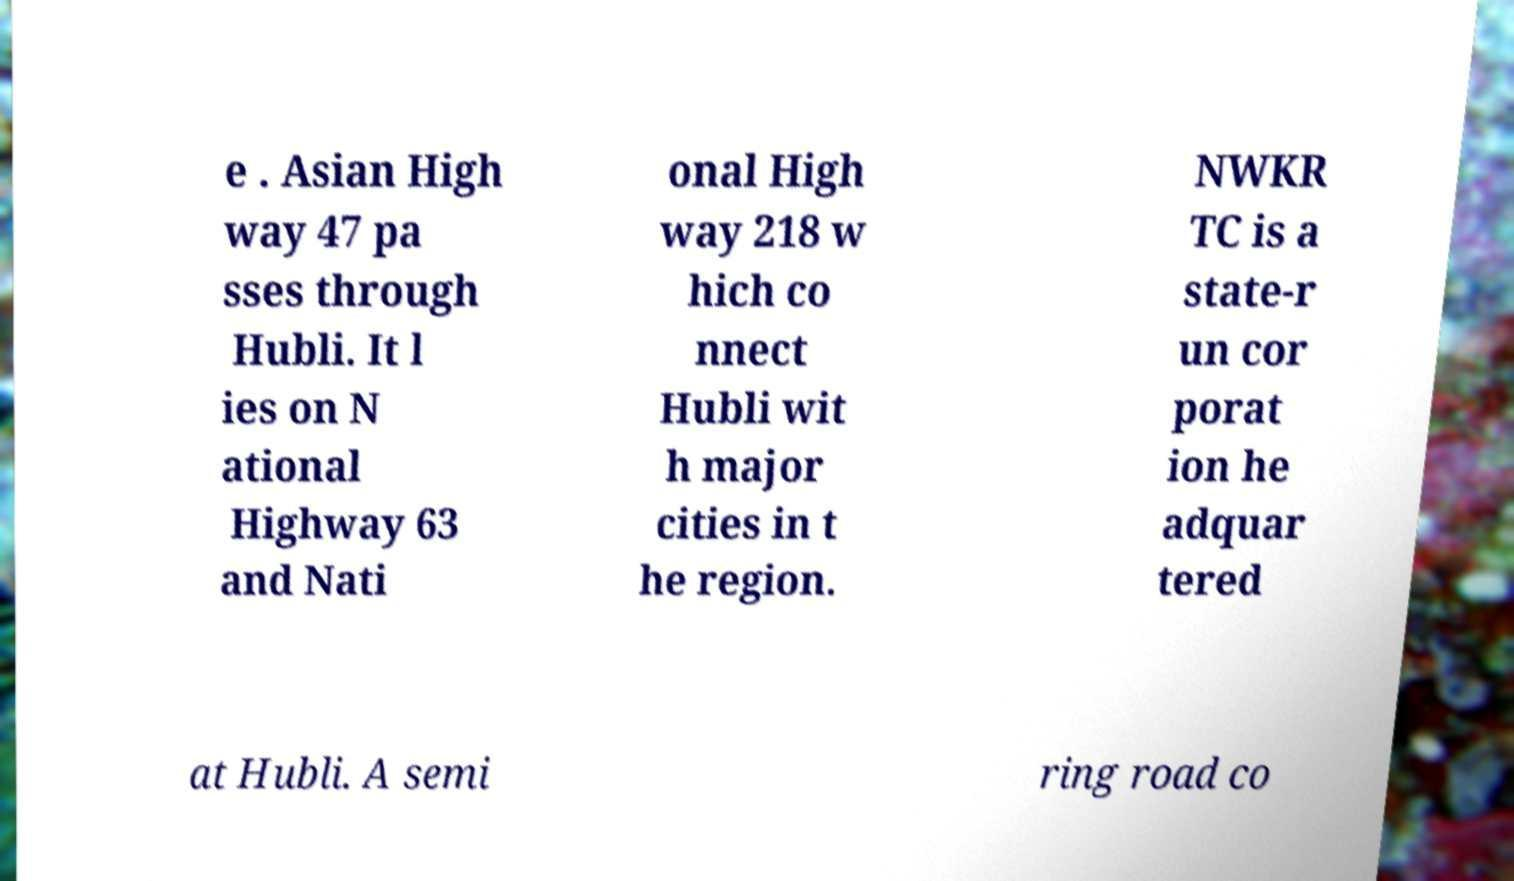Please read and relay the text visible in this image. What does it say? e . Asian High way 47 pa sses through Hubli. It l ies on N ational Highway 63 and Nati onal High way 218 w hich co nnect Hubli wit h major cities in t he region. NWKR TC is a state-r un cor porat ion he adquar tered at Hubli. A semi ring road co 